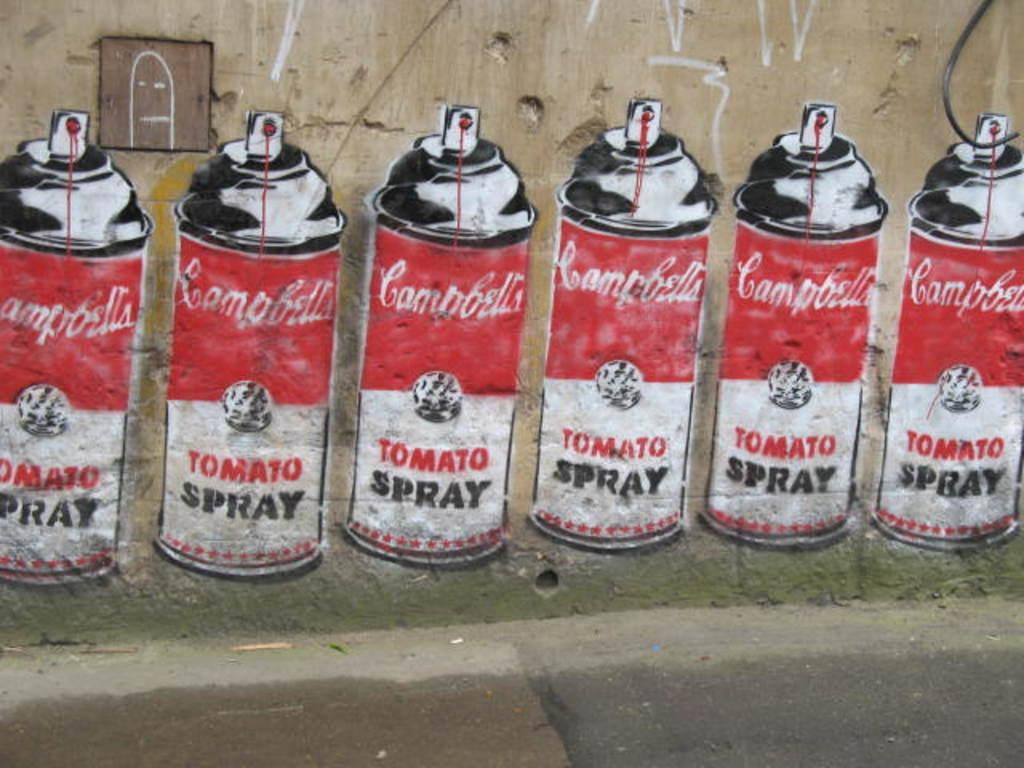<image>
Provide a brief description of the given image. Six cans of Campbell's Tomato Spray are painted on the wall here. 